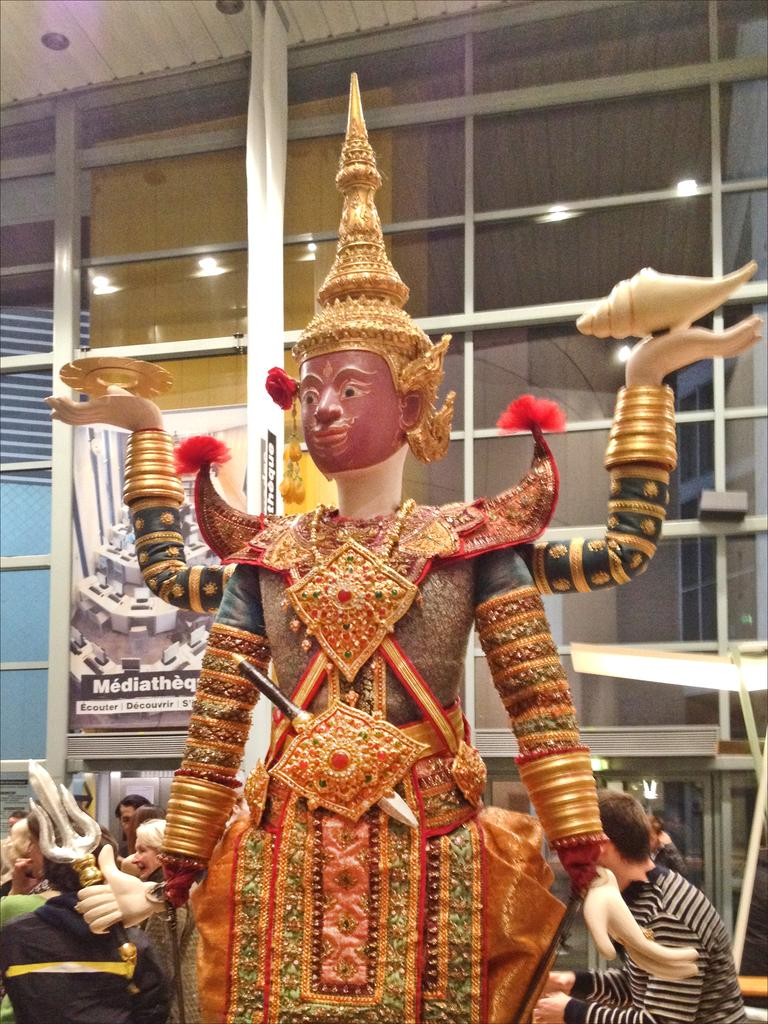What is the main setting of the image? The image is of a room. What can be seen in the foreground of the room? There is an idol in the foreground of the room. What are the people in the room doing? There is a group of people sitting in the back of the room. What is on the wall in the room? There is a hoarding on the wall in the room. What is the source of illumination in the room? There are lights in the room. How does the steam escape from the idol in the image? There is no steam present in the image; it is an idol made of a solid material. 